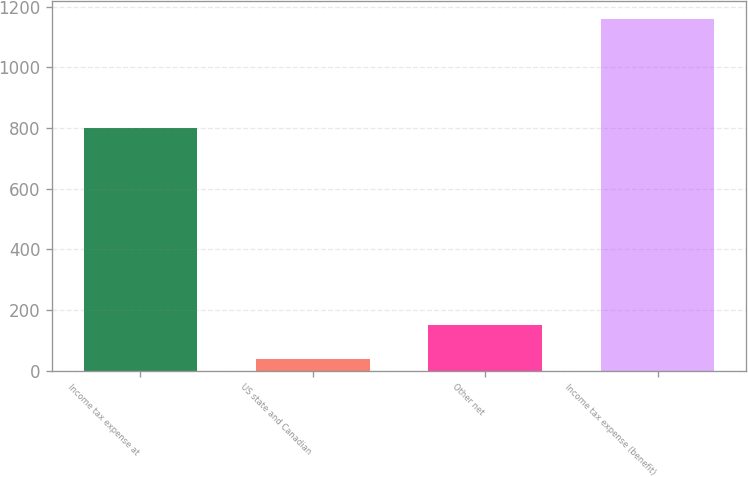Convert chart to OTSL. <chart><loc_0><loc_0><loc_500><loc_500><bar_chart><fcel>Income tax expense at<fcel>US state and Canadian<fcel>Other net<fcel>Income tax expense (benefit)<nl><fcel>799<fcel>37<fcel>149.3<fcel>1160<nl></chart> 